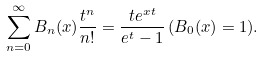<formula> <loc_0><loc_0><loc_500><loc_500>\sum ^ { \infty } _ { n = 0 } B _ { n } ( x ) \frac { t ^ { n } } { n ! } = \frac { t e ^ { x t } } { e ^ { t } - 1 } \, ( B _ { 0 } ( x ) = 1 ) .</formula> 